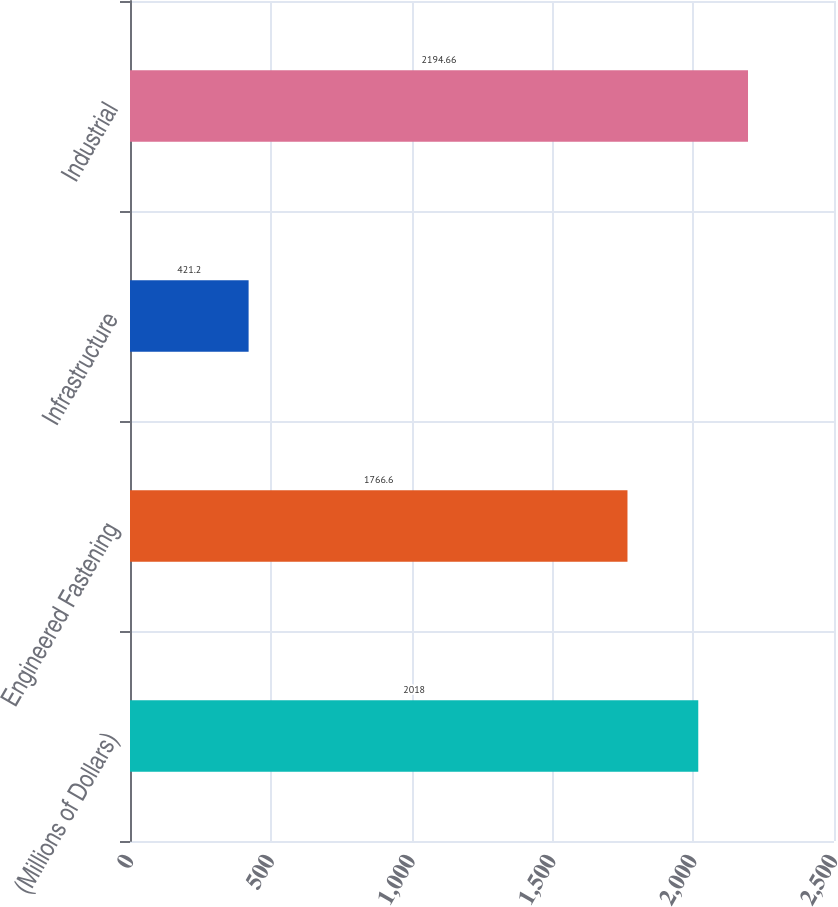Convert chart. <chart><loc_0><loc_0><loc_500><loc_500><bar_chart><fcel>(Millions of Dollars)<fcel>Engineered Fastening<fcel>Infrastructure<fcel>Industrial<nl><fcel>2018<fcel>1766.6<fcel>421.2<fcel>2194.66<nl></chart> 